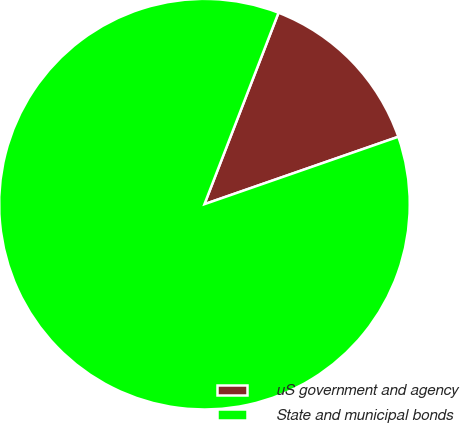Convert chart. <chart><loc_0><loc_0><loc_500><loc_500><pie_chart><fcel>uS government and agency<fcel>State and municipal bonds<nl><fcel>13.8%<fcel>86.2%<nl></chart> 